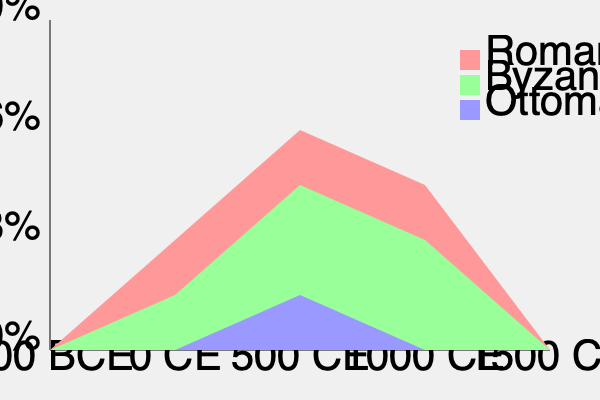Based on the stacked area chart depicting the rise and fall of empires from 500 BCE to 1500 CE, which empire reached its peak earliest and what approximate year did this occur? To answer this question, we need to analyze the chart step-by-step:

1. The chart shows three empires: Roman (red), Byzantine (green), and Ottoman (blue).

2. The x-axis represents time from 500 BCE to 1500 CE, divided into 500-year intervals.

3. The y-axis represents the relative power or territorial extent of each empire, from 0% to 100%.

4. We need to identify which empire reaches its highest point first:

   a) Roman Empire (red): Peaks around the midpoint between 0 CE and 500 CE, approximately 250 CE.
   b) Byzantine Empire (green): Peaks around 500 CE.
   c) Ottoman Empire (blue): Peaks towards the end of the chart, around 1500 CE.

5. Comparing these peaks, we can see that the Roman Empire reaches its highest point first.

6. To estimate the year more precisely, we can see that the Roman Empire's peak is slightly before the midpoint between 0 CE and 500 CE, so we can approximate it to around 250 CE.

Therefore, the Roman Empire reached its peak earliest, around the year 250 CE.
Answer: Roman Empire, circa 250 CE 